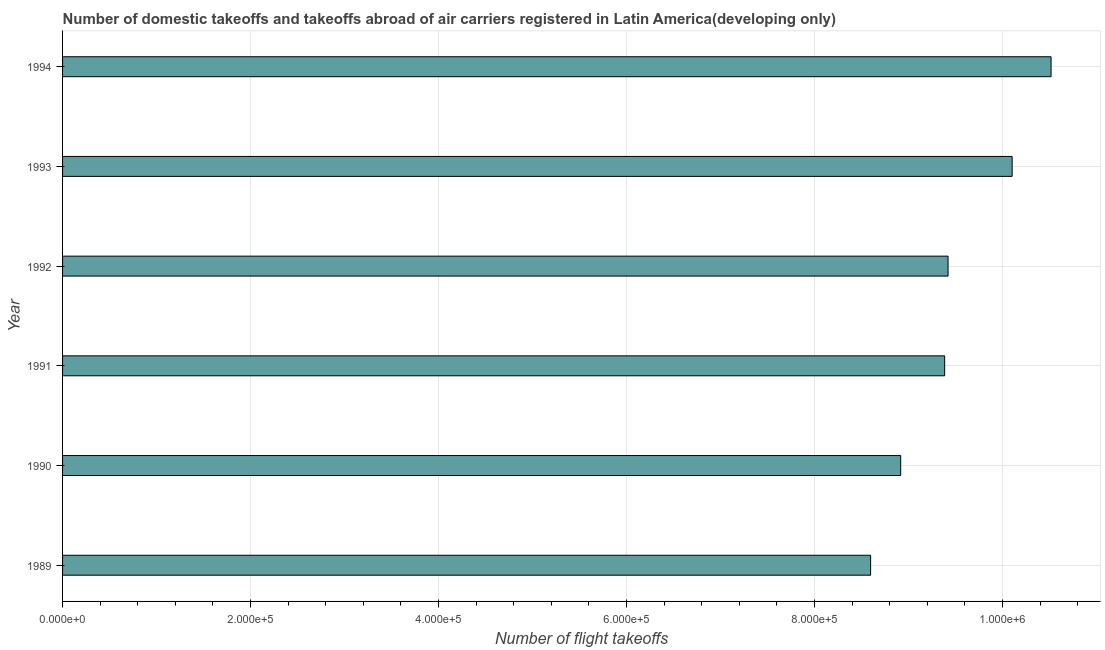Does the graph contain any zero values?
Make the answer very short. No. What is the title of the graph?
Keep it short and to the point. Number of domestic takeoffs and takeoffs abroad of air carriers registered in Latin America(developing only). What is the label or title of the X-axis?
Offer a terse response. Number of flight takeoffs. What is the label or title of the Y-axis?
Offer a terse response. Year. What is the number of flight takeoffs in 1991?
Your answer should be very brief. 9.38e+05. Across all years, what is the maximum number of flight takeoffs?
Give a very brief answer. 1.05e+06. Across all years, what is the minimum number of flight takeoffs?
Provide a short and direct response. 8.60e+05. In which year was the number of flight takeoffs minimum?
Keep it short and to the point. 1989. What is the sum of the number of flight takeoffs?
Provide a short and direct response. 5.69e+06. What is the difference between the number of flight takeoffs in 1991 and 1994?
Your answer should be compact. -1.13e+05. What is the average number of flight takeoffs per year?
Provide a succinct answer. 9.49e+05. What is the median number of flight takeoffs?
Provide a short and direct response. 9.40e+05. What is the ratio of the number of flight takeoffs in 1990 to that in 1991?
Make the answer very short. 0.95. Is the number of flight takeoffs in 1989 less than that in 1992?
Make the answer very short. Yes. Is the difference between the number of flight takeoffs in 1989 and 1992 greater than the difference between any two years?
Ensure brevity in your answer.  No. What is the difference between the highest and the second highest number of flight takeoffs?
Your answer should be very brief. 4.14e+04. Is the sum of the number of flight takeoffs in 1989 and 1993 greater than the maximum number of flight takeoffs across all years?
Give a very brief answer. Yes. What is the difference between the highest and the lowest number of flight takeoffs?
Your answer should be compact. 1.92e+05. In how many years, is the number of flight takeoffs greater than the average number of flight takeoffs taken over all years?
Make the answer very short. 2. How many years are there in the graph?
Make the answer very short. 6. What is the Number of flight takeoffs in 1989?
Make the answer very short. 8.60e+05. What is the Number of flight takeoffs in 1990?
Give a very brief answer. 8.92e+05. What is the Number of flight takeoffs in 1991?
Your response must be concise. 9.38e+05. What is the Number of flight takeoffs in 1992?
Provide a succinct answer. 9.42e+05. What is the Number of flight takeoffs in 1993?
Make the answer very short. 1.01e+06. What is the Number of flight takeoffs of 1994?
Your answer should be compact. 1.05e+06. What is the difference between the Number of flight takeoffs in 1989 and 1990?
Your answer should be compact. -3.20e+04. What is the difference between the Number of flight takeoffs in 1989 and 1991?
Ensure brevity in your answer.  -7.88e+04. What is the difference between the Number of flight takeoffs in 1989 and 1992?
Give a very brief answer. -8.24e+04. What is the difference between the Number of flight takeoffs in 1989 and 1993?
Keep it short and to the point. -1.51e+05. What is the difference between the Number of flight takeoffs in 1989 and 1994?
Offer a very short reply. -1.92e+05. What is the difference between the Number of flight takeoffs in 1990 and 1991?
Offer a very short reply. -4.68e+04. What is the difference between the Number of flight takeoffs in 1990 and 1992?
Your response must be concise. -5.04e+04. What is the difference between the Number of flight takeoffs in 1990 and 1993?
Give a very brief answer. -1.19e+05. What is the difference between the Number of flight takeoffs in 1990 and 1994?
Offer a terse response. -1.60e+05. What is the difference between the Number of flight takeoffs in 1991 and 1992?
Your response must be concise. -3600. What is the difference between the Number of flight takeoffs in 1991 and 1993?
Your answer should be compact. -7.18e+04. What is the difference between the Number of flight takeoffs in 1991 and 1994?
Offer a terse response. -1.13e+05. What is the difference between the Number of flight takeoffs in 1992 and 1993?
Your answer should be compact. -6.82e+04. What is the difference between the Number of flight takeoffs in 1992 and 1994?
Your answer should be compact. -1.10e+05. What is the difference between the Number of flight takeoffs in 1993 and 1994?
Offer a terse response. -4.14e+04. What is the ratio of the Number of flight takeoffs in 1989 to that in 1990?
Offer a very short reply. 0.96. What is the ratio of the Number of flight takeoffs in 1989 to that in 1991?
Provide a succinct answer. 0.92. What is the ratio of the Number of flight takeoffs in 1989 to that in 1993?
Make the answer very short. 0.85. What is the ratio of the Number of flight takeoffs in 1989 to that in 1994?
Make the answer very short. 0.82. What is the ratio of the Number of flight takeoffs in 1990 to that in 1992?
Give a very brief answer. 0.95. What is the ratio of the Number of flight takeoffs in 1990 to that in 1993?
Ensure brevity in your answer.  0.88. What is the ratio of the Number of flight takeoffs in 1990 to that in 1994?
Provide a short and direct response. 0.85. What is the ratio of the Number of flight takeoffs in 1991 to that in 1993?
Keep it short and to the point. 0.93. What is the ratio of the Number of flight takeoffs in 1991 to that in 1994?
Provide a succinct answer. 0.89. What is the ratio of the Number of flight takeoffs in 1992 to that in 1993?
Your answer should be compact. 0.93. What is the ratio of the Number of flight takeoffs in 1992 to that in 1994?
Your answer should be compact. 0.9. What is the ratio of the Number of flight takeoffs in 1993 to that in 1994?
Keep it short and to the point. 0.96. 